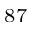Convert formula to latex. <formula><loc_0><loc_0><loc_500><loc_500>^ { 8 7 }</formula> 